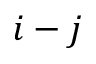<formula> <loc_0><loc_0><loc_500><loc_500>i - j</formula> 